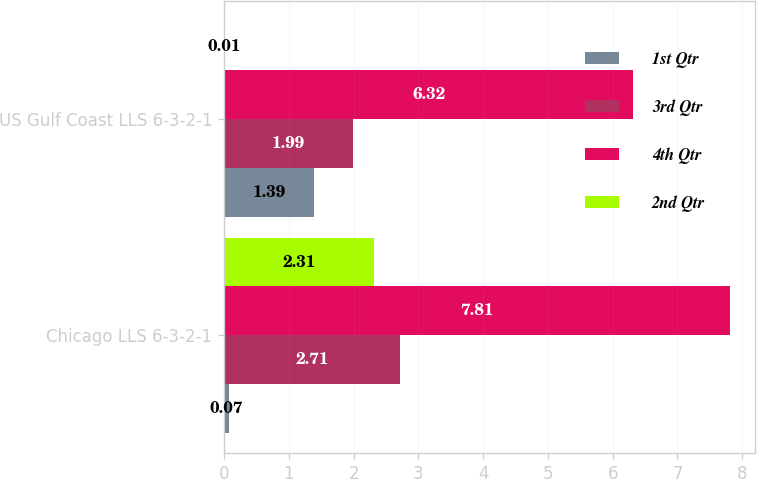Convert chart to OTSL. <chart><loc_0><loc_0><loc_500><loc_500><stacked_bar_chart><ecel><fcel>Chicago LLS 6-3-2-1<fcel>US Gulf Coast LLS 6-3-2-1<nl><fcel>1st Qtr<fcel>0.07<fcel>1.39<nl><fcel>3rd Qtr<fcel>2.71<fcel>1.99<nl><fcel>4th Qtr<fcel>7.81<fcel>6.32<nl><fcel>2nd Qtr<fcel>2.31<fcel>0.01<nl></chart> 